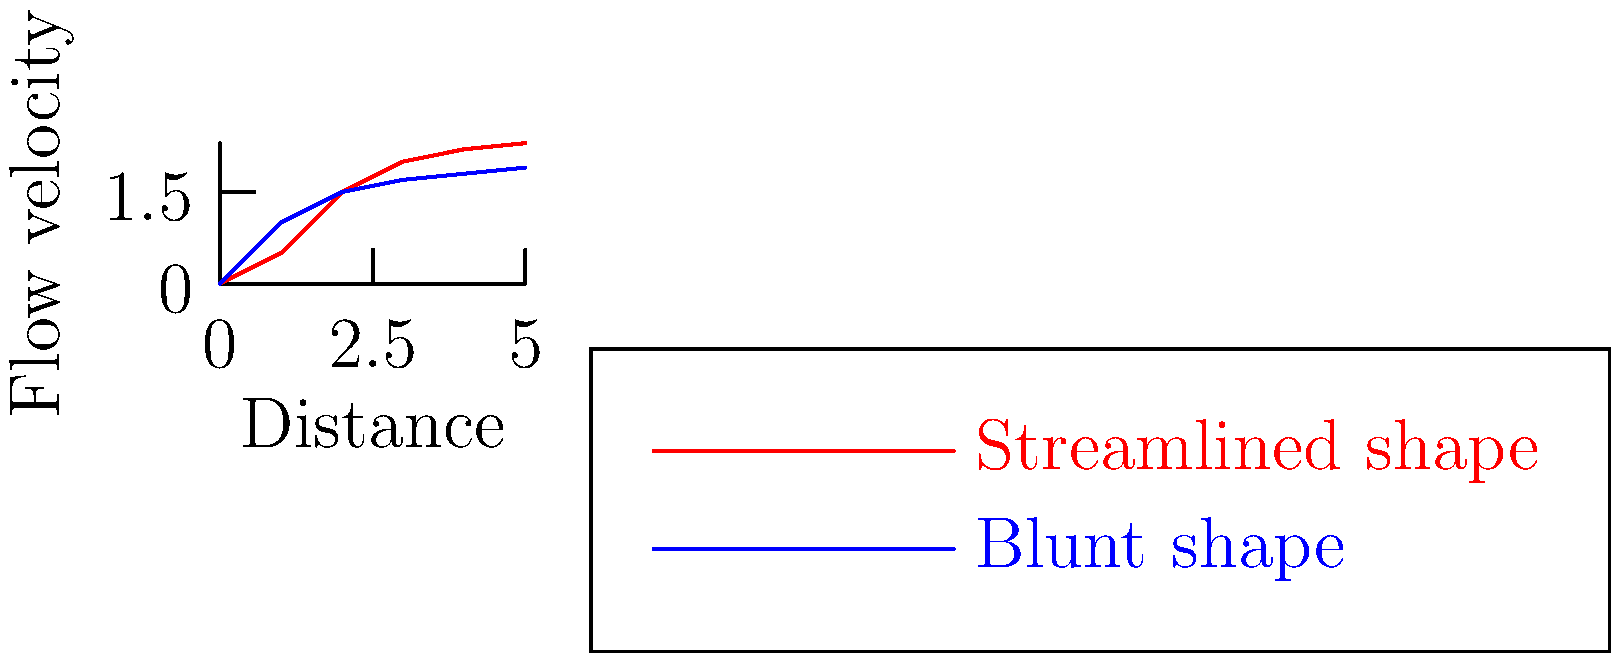As a spokesperson advocating for reduced regulations in industry, how would you interpret the fluid flow patterns shown in the graph for streamlined and blunt shapes? What implications might this have for design regulations in industries such as automotive or aerospace? 1. Analyze the graph:
   - The red line represents the flow around a streamlined shape
   - The blue line represents the flow around a blunt shape

2. Compare the flow patterns:
   - The streamlined shape (red) shows a more gradual increase in flow velocity
   - The blunt shape (blue) shows a rapid initial increase, then plateaus

3. Interpret the results:
   - Streamlined shapes create less turbulence and drag
   - Blunt shapes create more turbulence and drag

4. Consider the implications for industry:
   - Streamlined designs are more efficient, reducing fuel consumption
   - This leads to cost savings and reduced emissions

5. Relate to regulatory impact:
   - Strict design regulations might limit innovation in aerodynamics
   - Flexibility in regulations could allow for more efficient designs

6. Economic perspective:
   - Less regulation could lead to more diverse and innovative designs
   - This could result in more competitive products and economic growth

7. Conclusion:
   - Advocating for reduced regulations could promote innovation in aerodynamic design
   - This would lead to more efficient products and economic benefits
Answer: Reduced regulations would allow for more innovative aerodynamic designs, leading to increased efficiency and economic growth. 